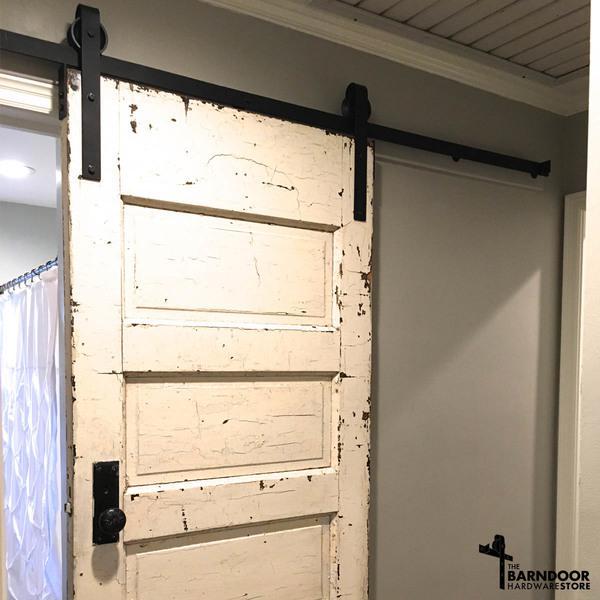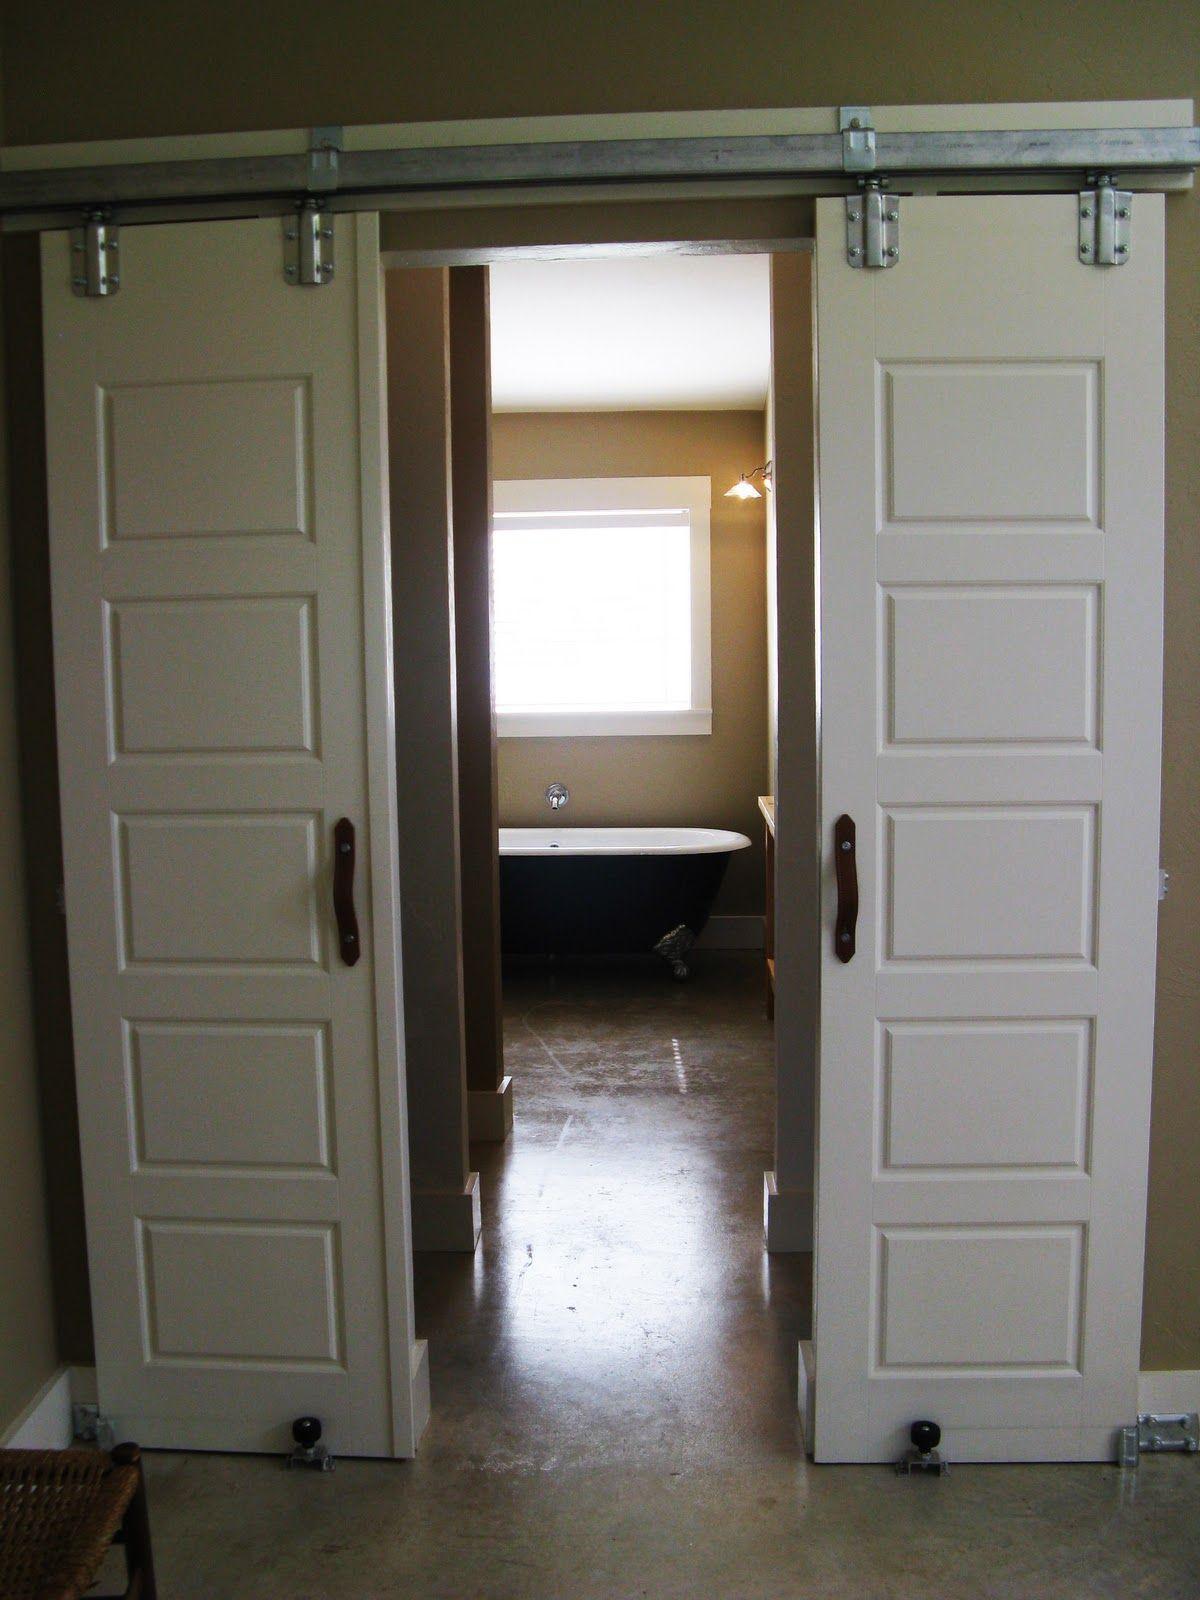The first image is the image on the left, the second image is the image on the right. Evaluate the accuracy of this statement regarding the images: "There is a bed in the image on the right.". Is it true? Answer yes or no. No. The first image is the image on the left, the second image is the image on the right. Considering the images on both sides, is "There is a white chair shown in one of the images." valid? Answer yes or no. No. 